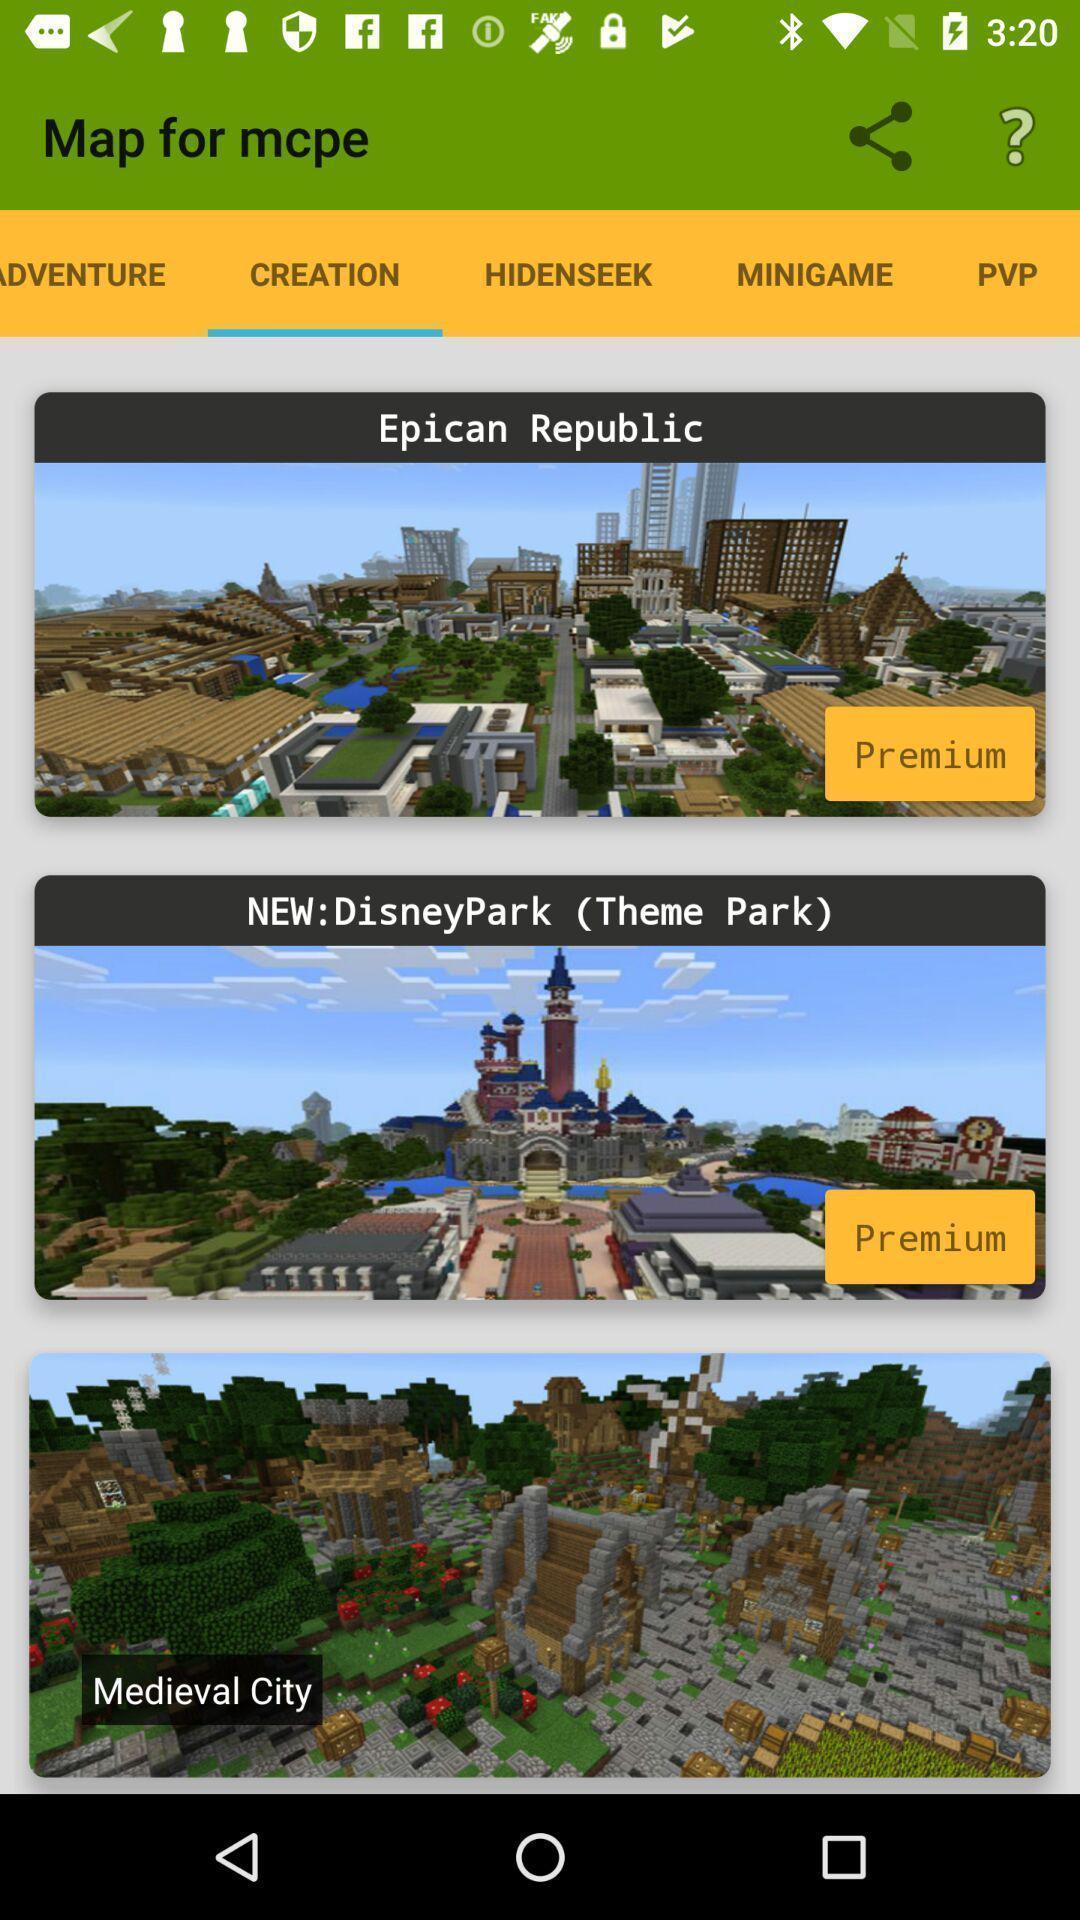Describe the visual elements of this screenshot. Page with different creations in a crafting and building app. 